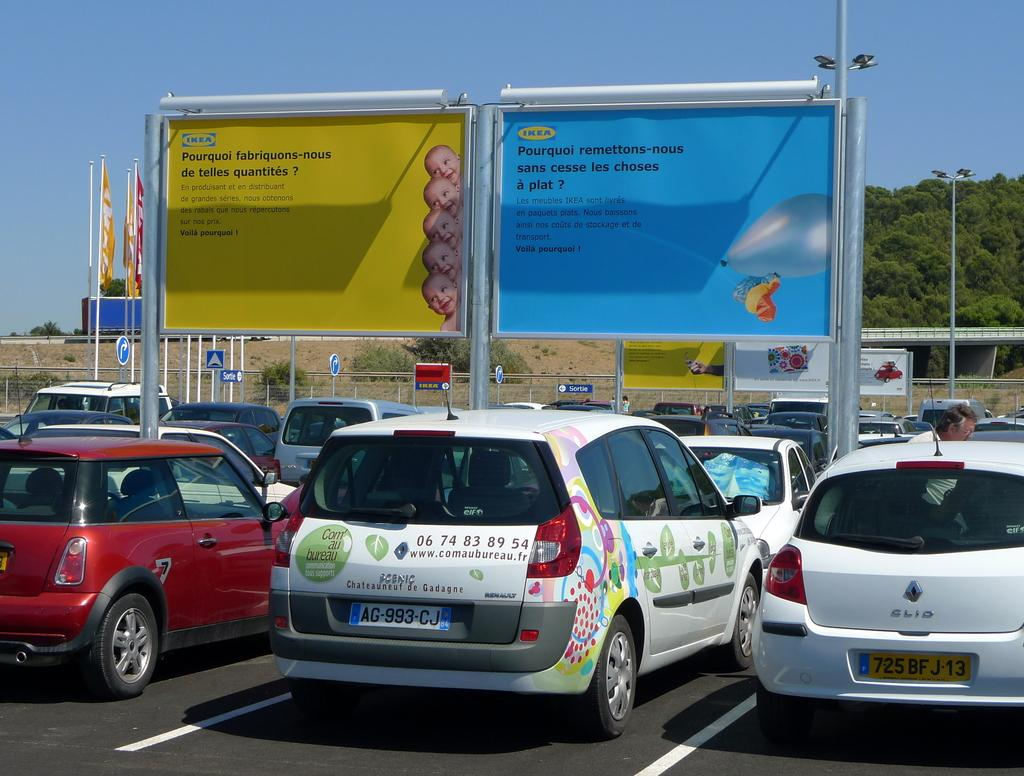What is happening with the vehicles in the image? Vehicles are parked on the road. Can you describe the background of the image? In the background, there are vehicles, a person, poles, sign boards, banners, lights, plants, trees, a bridge, and the sky. How many vehicles can be seen in the image? There are vehicles parked on the road and in the background, so at least two vehicles are visible. What type of ornament is the person kicking in the image? There is no person kicking an ornament in the image; the person is simply visible in the background. What material is the canvas used for the banners in the image? There is no mention of canvas in the image; the banners are made of unspecified materials. 